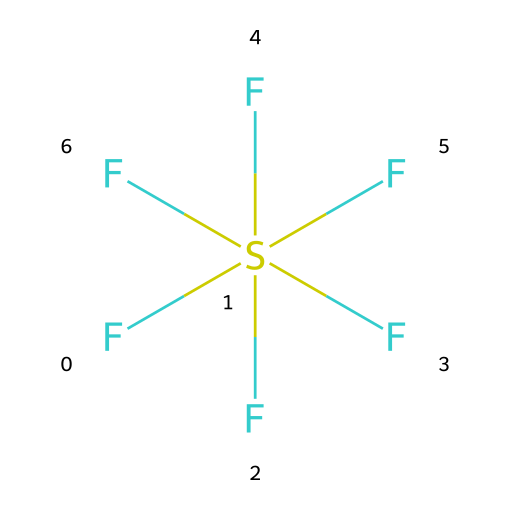What is the name of this chemical? The SMILES representation F[S](F)(F)(F)(F)F indicates that there is one sulfur atom bonded to six fluorine atoms, which confirms that the chemical is sulfur hexafluoride.
Answer: sulfur hexafluoride How many fluorine atoms are present? The SMILES structure lists six 'F' atoms attached to the sulfur atom, indicating there are six fluorine atoms present in the compound.
Answer: six What type of bonding is present in this compound? In the structure, sulfur is bonded to six fluorine atoms using single covalent bonds, which is characteristic of hypervalent compounds. This indicates the presence of covalent bonding throughout the molecule.
Answer: covalent Is sulfur hexafluoride a hypervalent compound? Since sulfur has six bonds (one with sulfur and five with fluorine), it exceeds the octet rule and classifies sulfur hexafluoride as a hypervalent compound.
Answer: yes What is the central atom in this compound? The central atom in the structure is sulfur, as it is the atom to which all the fluorine atoms are bonded.
Answer: sulfur How many total bonds are there in sulfur hexafluoride? The compound has six covalent bonds: one bond connecting the sulfur to each of the six fluorine atoms, leading to a total of six bonds in the molecule.
Answer: six 